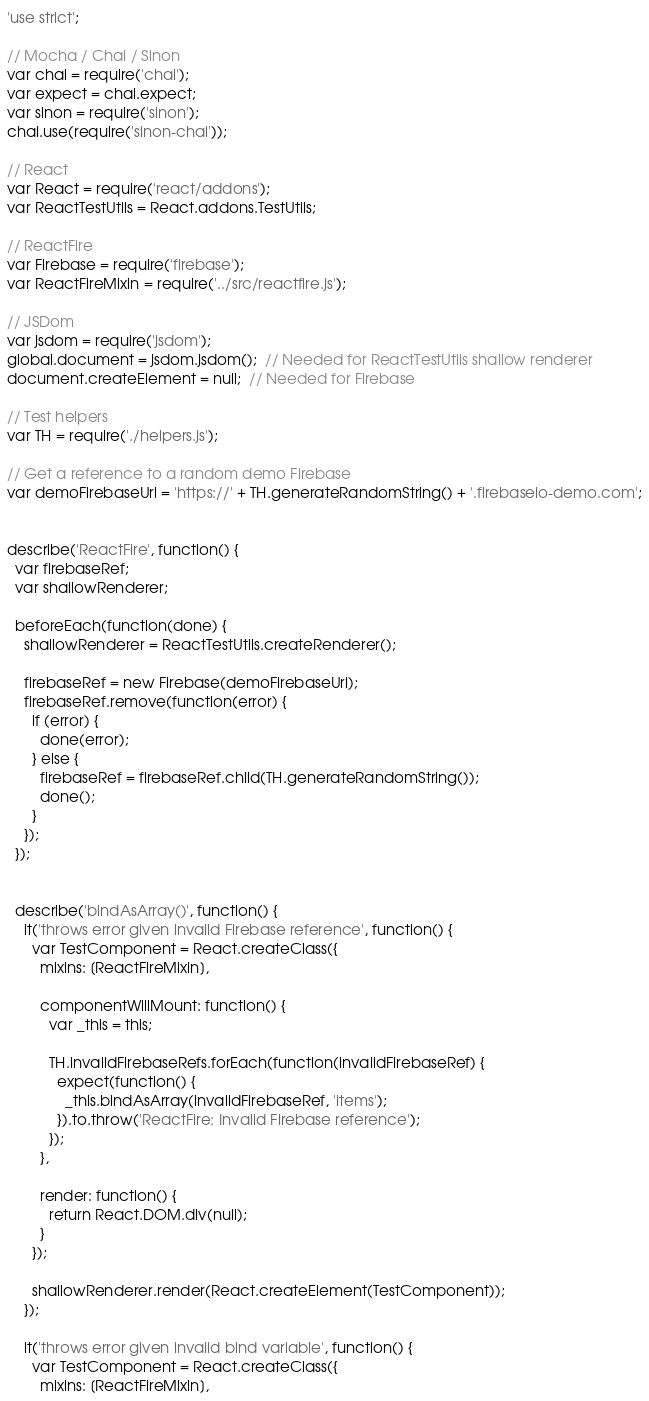<code> <loc_0><loc_0><loc_500><loc_500><_JavaScript_>'use strict';

// Mocha / Chai / Sinon
var chai = require('chai');
var expect = chai.expect;
var sinon = require('sinon');
chai.use(require('sinon-chai'));

// React
var React = require('react/addons');
var ReactTestUtils = React.addons.TestUtils;

// ReactFire
var Firebase = require('firebase');
var ReactFireMixin = require('../src/reactfire.js');

// JSDom
var jsdom = require('jsdom');
global.document = jsdom.jsdom();  // Needed for ReactTestUtils shallow renderer
document.createElement = null;  // Needed for Firebase

// Test helpers
var TH = require('./helpers.js');

// Get a reference to a random demo Firebase
var demoFirebaseUrl = 'https://' + TH.generateRandomString() + '.firebaseio-demo.com';


describe('ReactFire', function() {
  var firebaseRef;
  var shallowRenderer;

  beforeEach(function(done) {
    shallowRenderer = ReactTestUtils.createRenderer();

    firebaseRef = new Firebase(demoFirebaseUrl);
    firebaseRef.remove(function(error) {
      if (error) {
        done(error);
      } else {
        firebaseRef = firebaseRef.child(TH.generateRandomString());
        done();
      }
    });
  });


  describe('bindAsArray()', function() {
    it('throws error given invalid Firebase reference', function() {
      var TestComponent = React.createClass({
        mixins: [ReactFireMixin],

        componentWillMount: function() {
          var _this = this;

          TH.invalidFirebaseRefs.forEach(function(invalidFirebaseRef) {
            expect(function() {
              _this.bindAsArray(invalidFirebaseRef, 'items');
            }).to.throw('ReactFire: Invalid Firebase reference');
          });
        },

        render: function() {
          return React.DOM.div(null);
        }
      });

      shallowRenderer.render(React.createElement(TestComponent));
    });

    it('throws error given invalid bind variable', function() {
      var TestComponent = React.createClass({
        mixins: [ReactFireMixin],
</code> 